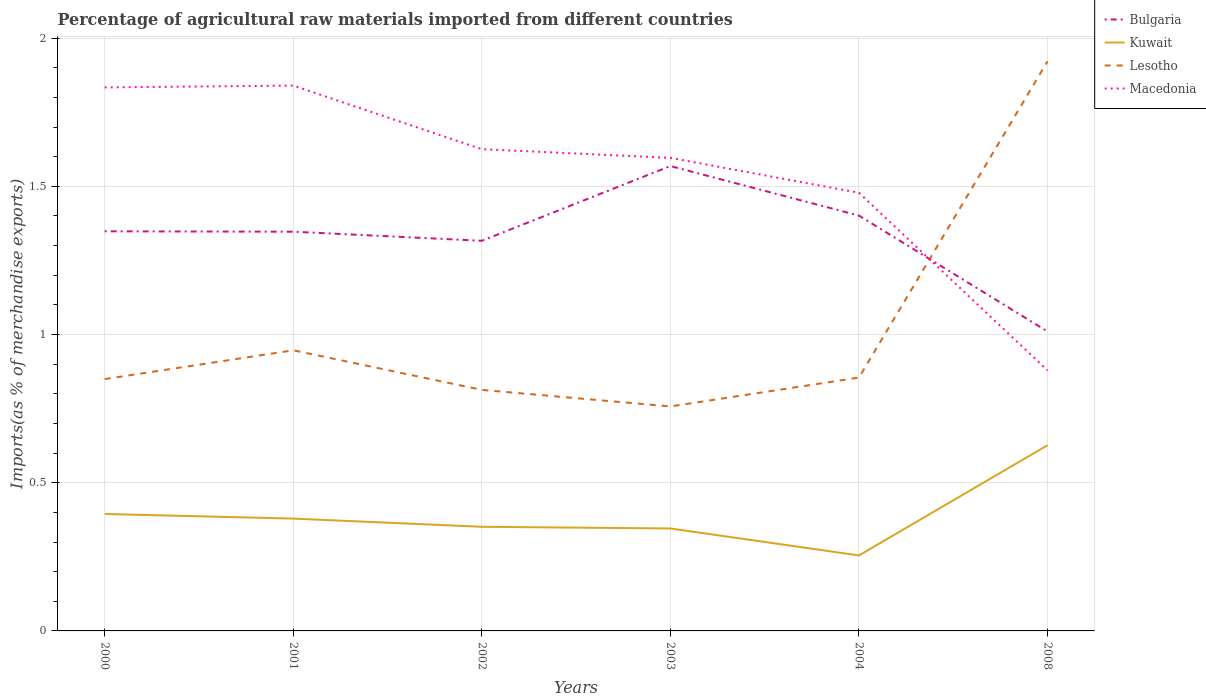How many different coloured lines are there?
Your response must be concise. 4. Is the number of lines equal to the number of legend labels?
Ensure brevity in your answer.  Yes. Across all years, what is the maximum percentage of imports to different countries in Bulgaria?
Provide a succinct answer. 1.01. What is the total percentage of imports to different countries in Kuwait in the graph?
Keep it short and to the point. 0.09. What is the difference between the highest and the second highest percentage of imports to different countries in Macedonia?
Your response must be concise. 0.96. What is the difference between the highest and the lowest percentage of imports to different countries in Bulgaria?
Keep it short and to the point. 4. How many lines are there?
Provide a succinct answer. 4. How are the legend labels stacked?
Keep it short and to the point. Vertical. What is the title of the graph?
Your response must be concise. Percentage of agricultural raw materials imported from different countries. Does "Kiribati" appear as one of the legend labels in the graph?
Ensure brevity in your answer.  No. What is the label or title of the X-axis?
Your answer should be compact. Years. What is the label or title of the Y-axis?
Offer a very short reply. Imports(as % of merchandise exports). What is the Imports(as % of merchandise exports) in Bulgaria in 2000?
Your answer should be compact. 1.35. What is the Imports(as % of merchandise exports) of Kuwait in 2000?
Ensure brevity in your answer.  0.39. What is the Imports(as % of merchandise exports) in Lesotho in 2000?
Your answer should be very brief. 0.85. What is the Imports(as % of merchandise exports) of Macedonia in 2000?
Your answer should be very brief. 1.83. What is the Imports(as % of merchandise exports) in Bulgaria in 2001?
Offer a very short reply. 1.35. What is the Imports(as % of merchandise exports) in Kuwait in 2001?
Keep it short and to the point. 0.38. What is the Imports(as % of merchandise exports) of Lesotho in 2001?
Provide a short and direct response. 0.95. What is the Imports(as % of merchandise exports) of Macedonia in 2001?
Offer a terse response. 1.84. What is the Imports(as % of merchandise exports) of Bulgaria in 2002?
Offer a very short reply. 1.32. What is the Imports(as % of merchandise exports) of Kuwait in 2002?
Offer a terse response. 0.35. What is the Imports(as % of merchandise exports) in Lesotho in 2002?
Your answer should be compact. 0.81. What is the Imports(as % of merchandise exports) of Macedonia in 2002?
Your answer should be very brief. 1.63. What is the Imports(as % of merchandise exports) in Bulgaria in 2003?
Offer a terse response. 1.57. What is the Imports(as % of merchandise exports) of Kuwait in 2003?
Keep it short and to the point. 0.35. What is the Imports(as % of merchandise exports) of Lesotho in 2003?
Keep it short and to the point. 0.76. What is the Imports(as % of merchandise exports) in Macedonia in 2003?
Ensure brevity in your answer.  1.6. What is the Imports(as % of merchandise exports) of Bulgaria in 2004?
Offer a terse response. 1.4. What is the Imports(as % of merchandise exports) in Kuwait in 2004?
Provide a short and direct response. 0.25. What is the Imports(as % of merchandise exports) in Lesotho in 2004?
Keep it short and to the point. 0.85. What is the Imports(as % of merchandise exports) of Macedonia in 2004?
Keep it short and to the point. 1.48. What is the Imports(as % of merchandise exports) of Bulgaria in 2008?
Provide a succinct answer. 1.01. What is the Imports(as % of merchandise exports) in Kuwait in 2008?
Your response must be concise. 0.63. What is the Imports(as % of merchandise exports) of Lesotho in 2008?
Your answer should be compact. 1.92. What is the Imports(as % of merchandise exports) in Macedonia in 2008?
Your answer should be compact. 0.88. Across all years, what is the maximum Imports(as % of merchandise exports) of Bulgaria?
Ensure brevity in your answer.  1.57. Across all years, what is the maximum Imports(as % of merchandise exports) in Kuwait?
Your response must be concise. 0.63. Across all years, what is the maximum Imports(as % of merchandise exports) of Lesotho?
Give a very brief answer. 1.92. Across all years, what is the maximum Imports(as % of merchandise exports) of Macedonia?
Your response must be concise. 1.84. Across all years, what is the minimum Imports(as % of merchandise exports) of Bulgaria?
Offer a very short reply. 1.01. Across all years, what is the minimum Imports(as % of merchandise exports) in Kuwait?
Offer a very short reply. 0.25. Across all years, what is the minimum Imports(as % of merchandise exports) of Lesotho?
Provide a succinct answer. 0.76. Across all years, what is the minimum Imports(as % of merchandise exports) in Macedonia?
Keep it short and to the point. 0.88. What is the total Imports(as % of merchandise exports) in Bulgaria in the graph?
Keep it short and to the point. 7.99. What is the total Imports(as % of merchandise exports) of Kuwait in the graph?
Give a very brief answer. 2.35. What is the total Imports(as % of merchandise exports) in Lesotho in the graph?
Provide a succinct answer. 6.14. What is the total Imports(as % of merchandise exports) of Macedonia in the graph?
Offer a terse response. 9.25. What is the difference between the Imports(as % of merchandise exports) of Bulgaria in 2000 and that in 2001?
Ensure brevity in your answer.  0. What is the difference between the Imports(as % of merchandise exports) of Kuwait in 2000 and that in 2001?
Your answer should be compact. 0.02. What is the difference between the Imports(as % of merchandise exports) in Lesotho in 2000 and that in 2001?
Ensure brevity in your answer.  -0.1. What is the difference between the Imports(as % of merchandise exports) of Macedonia in 2000 and that in 2001?
Your answer should be compact. -0.01. What is the difference between the Imports(as % of merchandise exports) of Bulgaria in 2000 and that in 2002?
Provide a short and direct response. 0.03. What is the difference between the Imports(as % of merchandise exports) of Kuwait in 2000 and that in 2002?
Your answer should be compact. 0.04. What is the difference between the Imports(as % of merchandise exports) of Lesotho in 2000 and that in 2002?
Your answer should be very brief. 0.04. What is the difference between the Imports(as % of merchandise exports) in Macedonia in 2000 and that in 2002?
Give a very brief answer. 0.21. What is the difference between the Imports(as % of merchandise exports) in Bulgaria in 2000 and that in 2003?
Offer a terse response. -0.22. What is the difference between the Imports(as % of merchandise exports) of Kuwait in 2000 and that in 2003?
Give a very brief answer. 0.05. What is the difference between the Imports(as % of merchandise exports) of Lesotho in 2000 and that in 2003?
Your answer should be very brief. 0.09. What is the difference between the Imports(as % of merchandise exports) in Macedonia in 2000 and that in 2003?
Ensure brevity in your answer.  0.24. What is the difference between the Imports(as % of merchandise exports) in Bulgaria in 2000 and that in 2004?
Your answer should be very brief. -0.05. What is the difference between the Imports(as % of merchandise exports) in Kuwait in 2000 and that in 2004?
Your answer should be very brief. 0.14. What is the difference between the Imports(as % of merchandise exports) of Lesotho in 2000 and that in 2004?
Your answer should be compact. -0.01. What is the difference between the Imports(as % of merchandise exports) of Macedonia in 2000 and that in 2004?
Keep it short and to the point. 0.36. What is the difference between the Imports(as % of merchandise exports) of Bulgaria in 2000 and that in 2008?
Make the answer very short. 0.34. What is the difference between the Imports(as % of merchandise exports) in Kuwait in 2000 and that in 2008?
Your response must be concise. -0.23. What is the difference between the Imports(as % of merchandise exports) of Lesotho in 2000 and that in 2008?
Your answer should be compact. -1.07. What is the difference between the Imports(as % of merchandise exports) in Macedonia in 2000 and that in 2008?
Ensure brevity in your answer.  0.95. What is the difference between the Imports(as % of merchandise exports) in Bulgaria in 2001 and that in 2002?
Provide a succinct answer. 0.03. What is the difference between the Imports(as % of merchandise exports) in Kuwait in 2001 and that in 2002?
Your answer should be compact. 0.03. What is the difference between the Imports(as % of merchandise exports) in Lesotho in 2001 and that in 2002?
Offer a very short reply. 0.13. What is the difference between the Imports(as % of merchandise exports) in Macedonia in 2001 and that in 2002?
Offer a very short reply. 0.21. What is the difference between the Imports(as % of merchandise exports) in Bulgaria in 2001 and that in 2003?
Keep it short and to the point. -0.22. What is the difference between the Imports(as % of merchandise exports) in Lesotho in 2001 and that in 2003?
Your response must be concise. 0.19. What is the difference between the Imports(as % of merchandise exports) in Macedonia in 2001 and that in 2003?
Ensure brevity in your answer.  0.24. What is the difference between the Imports(as % of merchandise exports) of Bulgaria in 2001 and that in 2004?
Your answer should be very brief. -0.05. What is the difference between the Imports(as % of merchandise exports) in Kuwait in 2001 and that in 2004?
Offer a very short reply. 0.12. What is the difference between the Imports(as % of merchandise exports) in Lesotho in 2001 and that in 2004?
Provide a succinct answer. 0.09. What is the difference between the Imports(as % of merchandise exports) of Macedonia in 2001 and that in 2004?
Your answer should be compact. 0.36. What is the difference between the Imports(as % of merchandise exports) of Bulgaria in 2001 and that in 2008?
Your answer should be very brief. 0.34. What is the difference between the Imports(as % of merchandise exports) of Kuwait in 2001 and that in 2008?
Give a very brief answer. -0.25. What is the difference between the Imports(as % of merchandise exports) of Lesotho in 2001 and that in 2008?
Your answer should be compact. -0.98. What is the difference between the Imports(as % of merchandise exports) in Macedonia in 2001 and that in 2008?
Your answer should be very brief. 0.96. What is the difference between the Imports(as % of merchandise exports) in Bulgaria in 2002 and that in 2003?
Provide a short and direct response. -0.25. What is the difference between the Imports(as % of merchandise exports) in Kuwait in 2002 and that in 2003?
Your answer should be very brief. 0.01. What is the difference between the Imports(as % of merchandise exports) in Lesotho in 2002 and that in 2003?
Your response must be concise. 0.06. What is the difference between the Imports(as % of merchandise exports) of Macedonia in 2002 and that in 2003?
Provide a succinct answer. 0.03. What is the difference between the Imports(as % of merchandise exports) in Bulgaria in 2002 and that in 2004?
Your answer should be compact. -0.09. What is the difference between the Imports(as % of merchandise exports) of Kuwait in 2002 and that in 2004?
Your response must be concise. 0.1. What is the difference between the Imports(as % of merchandise exports) in Lesotho in 2002 and that in 2004?
Provide a short and direct response. -0.04. What is the difference between the Imports(as % of merchandise exports) of Macedonia in 2002 and that in 2004?
Keep it short and to the point. 0.15. What is the difference between the Imports(as % of merchandise exports) of Bulgaria in 2002 and that in 2008?
Make the answer very short. 0.31. What is the difference between the Imports(as % of merchandise exports) of Kuwait in 2002 and that in 2008?
Give a very brief answer. -0.28. What is the difference between the Imports(as % of merchandise exports) in Lesotho in 2002 and that in 2008?
Offer a very short reply. -1.11. What is the difference between the Imports(as % of merchandise exports) of Macedonia in 2002 and that in 2008?
Make the answer very short. 0.75. What is the difference between the Imports(as % of merchandise exports) of Bulgaria in 2003 and that in 2004?
Give a very brief answer. 0.17. What is the difference between the Imports(as % of merchandise exports) of Kuwait in 2003 and that in 2004?
Ensure brevity in your answer.  0.09. What is the difference between the Imports(as % of merchandise exports) of Lesotho in 2003 and that in 2004?
Give a very brief answer. -0.1. What is the difference between the Imports(as % of merchandise exports) of Macedonia in 2003 and that in 2004?
Offer a terse response. 0.12. What is the difference between the Imports(as % of merchandise exports) of Bulgaria in 2003 and that in 2008?
Offer a very short reply. 0.56. What is the difference between the Imports(as % of merchandise exports) of Kuwait in 2003 and that in 2008?
Your answer should be compact. -0.28. What is the difference between the Imports(as % of merchandise exports) of Lesotho in 2003 and that in 2008?
Keep it short and to the point. -1.16. What is the difference between the Imports(as % of merchandise exports) of Macedonia in 2003 and that in 2008?
Ensure brevity in your answer.  0.72. What is the difference between the Imports(as % of merchandise exports) of Bulgaria in 2004 and that in 2008?
Your answer should be compact. 0.39. What is the difference between the Imports(as % of merchandise exports) of Kuwait in 2004 and that in 2008?
Make the answer very short. -0.37. What is the difference between the Imports(as % of merchandise exports) in Lesotho in 2004 and that in 2008?
Keep it short and to the point. -1.07. What is the difference between the Imports(as % of merchandise exports) of Macedonia in 2004 and that in 2008?
Ensure brevity in your answer.  0.6. What is the difference between the Imports(as % of merchandise exports) of Bulgaria in 2000 and the Imports(as % of merchandise exports) of Kuwait in 2001?
Keep it short and to the point. 0.97. What is the difference between the Imports(as % of merchandise exports) of Bulgaria in 2000 and the Imports(as % of merchandise exports) of Lesotho in 2001?
Offer a very short reply. 0.4. What is the difference between the Imports(as % of merchandise exports) in Bulgaria in 2000 and the Imports(as % of merchandise exports) in Macedonia in 2001?
Make the answer very short. -0.49. What is the difference between the Imports(as % of merchandise exports) in Kuwait in 2000 and the Imports(as % of merchandise exports) in Lesotho in 2001?
Provide a succinct answer. -0.55. What is the difference between the Imports(as % of merchandise exports) in Kuwait in 2000 and the Imports(as % of merchandise exports) in Macedonia in 2001?
Offer a very short reply. -1.45. What is the difference between the Imports(as % of merchandise exports) in Lesotho in 2000 and the Imports(as % of merchandise exports) in Macedonia in 2001?
Offer a terse response. -0.99. What is the difference between the Imports(as % of merchandise exports) in Bulgaria in 2000 and the Imports(as % of merchandise exports) in Kuwait in 2002?
Offer a very short reply. 1. What is the difference between the Imports(as % of merchandise exports) in Bulgaria in 2000 and the Imports(as % of merchandise exports) in Lesotho in 2002?
Offer a terse response. 0.54. What is the difference between the Imports(as % of merchandise exports) in Bulgaria in 2000 and the Imports(as % of merchandise exports) in Macedonia in 2002?
Your answer should be very brief. -0.28. What is the difference between the Imports(as % of merchandise exports) in Kuwait in 2000 and the Imports(as % of merchandise exports) in Lesotho in 2002?
Ensure brevity in your answer.  -0.42. What is the difference between the Imports(as % of merchandise exports) of Kuwait in 2000 and the Imports(as % of merchandise exports) of Macedonia in 2002?
Offer a terse response. -1.23. What is the difference between the Imports(as % of merchandise exports) of Lesotho in 2000 and the Imports(as % of merchandise exports) of Macedonia in 2002?
Make the answer very short. -0.78. What is the difference between the Imports(as % of merchandise exports) of Bulgaria in 2000 and the Imports(as % of merchandise exports) of Kuwait in 2003?
Provide a succinct answer. 1. What is the difference between the Imports(as % of merchandise exports) in Bulgaria in 2000 and the Imports(as % of merchandise exports) in Lesotho in 2003?
Provide a succinct answer. 0.59. What is the difference between the Imports(as % of merchandise exports) in Bulgaria in 2000 and the Imports(as % of merchandise exports) in Macedonia in 2003?
Provide a succinct answer. -0.25. What is the difference between the Imports(as % of merchandise exports) of Kuwait in 2000 and the Imports(as % of merchandise exports) of Lesotho in 2003?
Keep it short and to the point. -0.36. What is the difference between the Imports(as % of merchandise exports) of Kuwait in 2000 and the Imports(as % of merchandise exports) of Macedonia in 2003?
Make the answer very short. -1.2. What is the difference between the Imports(as % of merchandise exports) in Lesotho in 2000 and the Imports(as % of merchandise exports) in Macedonia in 2003?
Offer a very short reply. -0.75. What is the difference between the Imports(as % of merchandise exports) of Bulgaria in 2000 and the Imports(as % of merchandise exports) of Kuwait in 2004?
Offer a terse response. 1.09. What is the difference between the Imports(as % of merchandise exports) in Bulgaria in 2000 and the Imports(as % of merchandise exports) in Lesotho in 2004?
Give a very brief answer. 0.49. What is the difference between the Imports(as % of merchandise exports) of Bulgaria in 2000 and the Imports(as % of merchandise exports) of Macedonia in 2004?
Offer a terse response. -0.13. What is the difference between the Imports(as % of merchandise exports) in Kuwait in 2000 and the Imports(as % of merchandise exports) in Lesotho in 2004?
Provide a short and direct response. -0.46. What is the difference between the Imports(as % of merchandise exports) in Kuwait in 2000 and the Imports(as % of merchandise exports) in Macedonia in 2004?
Offer a very short reply. -1.08. What is the difference between the Imports(as % of merchandise exports) of Lesotho in 2000 and the Imports(as % of merchandise exports) of Macedonia in 2004?
Keep it short and to the point. -0.63. What is the difference between the Imports(as % of merchandise exports) of Bulgaria in 2000 and the Imports(as % of merchandise exports) of Kuwait in 2008?
Your answer should be compact. 0.72. What is the difference between the Imports(as % of merchandise exports) in Bulgaria in 2000 and the Imports(as % of merchandise exports) in Lesotho in 2008?
Provide a succinct answer. -0.57. What is the difference between the Imports(as % of merchandise exports) in Bulgaria in 2000 and the Imports(as % of merchandise exports) in Macedonia in 2008?
Give a very brief answer. 0.47. What is the difference between the Imports(as % of merchandise exports) in Kuwait in 2000 and the Imports(as % of merchandise exports) in Lesotho in 2008?
Make the answer very short. -1.53. What is the difference between the Imports(as % of merchandise exports) of Kuwait in 2000 and the Imports(as % of merchandise exports) of Macedonia in 2008?
Keep it short and to the point. -0.48. What is the difference between the Imports(as % of merchandise exports) in Lesotho in 2000 and the Imports(as % of merchandise exports) in Macedonia in 2008?
Provide a short and direct response. -0.03. What is the difference between the Imports(as % of merchandise exports) in Bulgaria in 2001 and the Imports(as % of merchandise exports) in Lesotho in 2002?
Offer a very short reply. 0.53. What is the difference between the Imports(as % of merchandise exports) of Bulgaria in 2001 and the Imports(as % of merchandise exports) of Macedonia in 2002?
Your response must be concise. -0.28. What is the difference between the Imports(as % of merchandise exports) in Kuwait in 2001 and the Imports(as % of merchandise exports) in Lesotho in 2002?
Offer a terse response. -0.43. What is the difference between the Imports(as % of merchandise exports) in Kuwait in 2001 and the Imports(as % of merchandise exports) in Macedonia in 2002?
Provide a short and direct response. -1.25. What is the difference between the Imports(as % of merchandise exports) of Lesotho in 2001 and the Imports(as % of merchandise exports) of Macedonia in 2002?
Offer a terse response. -0.68. What is the difference between the Imports(as % of merchandise exports) in Bulgaria in 2001 and the Imports(as % of merchandise exports) in Lesotho in 2003?
Your answer should be very brief. 0.59. What is the difference between the Imports(as % of merchandise exports) in Bulgaria in 2001 and the Imports(as % of merchandise exports) in Macedonia in 2003?
Offer a terse response. -0.25. What is the difference between the Imports(as % of merchandise exports) in Kuwait in 2001 and the Imports(as % of merchandise exports) in Lesotho in 2003?
Offer a very short reply. -0.38. What is the difference between the Imports(as % of merchandise exports) of Kuwait in 2001 and the Imports(as % of merchandise exports) of Macedonia in 2003?
Provide a succinct answer. -1.22. What is the difference between the Imports(as % of merchandise exports) of Lesotho in 2001 and the Imports(as % of merchandise exports) of Macedonia in 2003?
Ensure brevity in your answer.  -0.65. What is the difference between the Imports(as % of merchandise exports) in Bulgaria in 2001 and the Imports(as % of merchandise exports) in Kuwait in 2004?
Keep it short and to the point. 1.09. What is the difference between the Imports(as % of merchandise exports) in Bulgaria in 2001 and the Imports(as % of merchandise exports) in Lesotho in 2004?
Make the answer very short. 0.49. What is the difference between the Imports(as % of merchandise exports) of Bulgaria in 2001 and the Imports(as % of merchandise exports) of Macedonia in 2004?
Offer a terse response. -0.13. What is the difference between the Imports(as % of merchandise exports) in Kuwait in 2001 and the Imports(as % of merchandise exports) in Lesotho in 2004?
Keep it short and to the point. -0.48. What is the difference between the Imports(as % of merchandise exports) of Kuwait in 2001 and the Imports(as % of merchandise exports) of Macedonia in 2004?
Your answer should be compact. -1.1. What is the difference between the Imports(as % of merchandise exports) in Lesotho in 2001 and the Imports(as % of merchandise exports) in Macedonia in 2004?
Make the answer very short. -0.53. What is the difference between the Imports(as % of merchandise exports) of Bulgaria in 2001 and the Imports(as % of merchandise exports) of Kuwait in 2008?
Give a very brief answer. 0.72. What is the difference between the Imports(as % of merchandise exports) of Bulgaria in 2001 and the Imports(as % of merchandise exports) of Lesotho in 2008?
Make the answer very short. -0.57. What is the difference between the Imports(as % of merchandise exports) of Bulgaria in 2001 and the Imports(as % of merchandise exports) of Macedonia in 2008?
Your response must be concise. 0.47. What is the difference between the Imports(as % of merchandise exports) in Kuwait in 2001 and the Imports(as % of merchandise exports) in Lesotho in 2008?
Your response must be concise. -1.54. What is the difference between the Imports(as % of merchandise exports) in Kuwait in 2001 and the Imports(as % of merchandise exports) in Macedonia in 2008?
Offer a terse response. -0.5. What is the difference between the Imports(as % of merchandise exports) in Lesotho in 2001 and the Imports(as % of merchandise exports) in Macedonia in 2008?
Keep it short and to the point. 0.07. What is the difference between the Imports(as % of merchandise exports) of Bulgaria in 2002 and the Imports(as % of merchandise exports) of Kuwait in 2003?
Offer a very short reply. 0.97. What is the difference between the Imports(as % of merchandise exports) in Bulgaria in 2002 and the Imports(as % of merchandise exports) in Lesotho in 2003?
Make the answer very short. 0.56. What is the difference between the Imports(as % of merchandise exports) of Bulgaria in 2002 and the Imports(as % of merchandise exports) of Macedonia in 2003?
Keep it short and to the point. -0.28. What is the difference between the Imports(as % of merchandise exports) of Kuwait in 2002 and the Imports(as % of merchandise exports) of Lesotho in 2003?
Make the answer very short. -0.41. What is the difference between the Imports(as % of merchandise exports) of Kuwait in 2002 and the Imports(as % of merchandise exports) of Macedonia in 2003?
Offer a terse response. -1.24. What is the difference between the Imports(as % of merchandise exports) in Lesotho in 2002 and the Imports(as % of merchandise exports) in Macedonia in 2003?
Offer a very short reply. -0.78. What is the difference between the Imports(as % of merchandise exports) in Bulgaria in 2002 and the Imports(as % of merchandise exports) in Kuwait in 2004?
Your response must be concise. 1.06. What is the difference between the Imports(as % of merchandise exports) in Bulgaria in 2002 and the Imports(as % of merchandise exports) in Lesotho in 2004?
Provide a short and direct response. 0.46. What is the difference between the Imports(as % of merchandise exports) of Bulgaria in 2002 and the Imports(as % of merchandise exports) of Macedonia in 2004?
Your answer should be compact. -0.16. What is the difference between the Imports(as % of merchandise exports) of Kuwait in 2002 and the Imports(as % of merchandise exports) of Lesotho in 2004?
Your answer should be compact. -0.5. What is the difference between the Imports(as % of merchandise exports) of Kuwait in 2002 and the Imports(as % of merchandise exports) of Macedonia in 2004?
Keep it short and to the point. -1.13. What is the difference between the Imports(as % of merchandise exports) of Lesotho in 2002 and the Imports(as % of merchandise exports) of Macedonia in 2004?
Your answer should be very brief. -0.67. What is the difference between the Imports(as % of merchandise exports) in Bulgaria in 2002 and the Imports(as % of merchandise exports) in Kuwait in 2008?
Ensure brevity in your answer.  0.69. What is the difference between the Imports(as % of merchandise exports) in Bulgaria in 2002 and the Imports(as % of merchandise exports) in Lesotho in 2008?
Keep it short and to the point. -0.61. What is the difference between the Imports(as % of merchandise exports) of Bulgaria in 2002 and the Imports(as % of merchandise exports) of Macedonia in 2008?
Provide a short and direct response. 0.44. What is the difference between the Imports(as % of merchandise exports) in Kuwait in 2002 and the Imports(as % of merchandise exports) in Lesotho in 2008?
Keep it short and to the point. -1.57. What is the difference between the Imports(as % of merchandise exports) in Kuwait in 2002 and the Imports(as % of merchandise exports) in Macedonia in 2008?
Keep it short and to the point. -0.53. What is the difference between the Imports(as % of merchandise exports) in Lesotho in 2002 and the Imports(as % of merchandise exports) in Macedonia in 2008?
Provide a short and direct response. -0.07. What is the difference between the Imports(as % of merchandise exports) of Bulgaria in 2003 and the Imports(as % of merchandise exports) of Kuwait in 2004?
Offer a terse response. 1.31. What is the difference between the Imports(as % of merchandise exports) of Bulgaria in 2003 and the Imports(as % of merchandise exports) of Lesotho in 2004?
Provide a succinct answer. 0.71. What is the difference between the Imports(as % of merchandise exports) of Bulgaria in 2003 and the Imports(as % of merchandise exports) of Macedonia in 2004?
Offer a terse response. 0.09. What is the difference between the Imports(as % of merchandise exports) of Kuwait in 2003 and the Imports(as % of merchandise exports) of Lesotho in 2004?
Provide a short and direct response. -0.51. What is the difference between the Imports(as % of merchandise exports) of Kuwait in 2003 and the Imports(as % of merchandise exports) of Macedonia in 2004?
Offer a terse response. -1.13. What is the difference between the Imports(as % of merchandise exports) in Lesotho in 2003 and the Imports(as % of merchandise exports) in Macedonia in 2004?
Your response must be concise. -0.72. What is the difference between the Imports(as % of merchandise exports) in Bulgaria in 2003 and the Imports(as % of merchandise exports) in Kuwait in 2008?
Ensure brevity in your answer.  0.94. What is the difference between the Imports(as % of merchandise exports) in Bulgaria in 2003 and the Imports(as % of merchandise exports) in Lesotho in 2008?
Keep it short and to the point. -0.35. What is the difference between the Imports(as % of merchandise exports) of Bulgaria in 2003 and the Imports(as % of merchandise exports) of Macedonia in 2008?
Make the answer very short. 0.69. What is the difference between the Imports(as % of merchandise exports) in Kuwait in 2003 and the Imports(as % of merchandise exports) in Lesotho in 2008?
Your answer should be very brief. -1.58. What is the difference between the Imports(as % of merchandise exports) of Kuwait in 2003 and the Imports(as % of merchandise exports) of Macedonia in 2008?
Your answer should be very brief. -0.53. What is the difference between the Imports(as % of merchandise exports) of Lesotho in 2003 and the Imports(as % of merchandise exports) of Macedonia in 2008?
Your response must be concise. -0.12. What is the difference between the Imports(as % of merchandise exports) in Bulgaria in 2004 and the Imports(as % of merchandise exports) in Kuwait in 2008?
Your response must be concise. 0.77. What is the difference between the Imports(as % of merchandise exports) of Bulgaria in 2004 and the Imports(as % of merchandise exports) of Lesotho in 2008?
Provide a short and direct response. -0.52. What is the difference between the Imports(as % of merchandise exports) of Bulgaria in 2004 and the Imports(as % of merchandise exports) of Macedonia in 2008?
Your answer should be very brief. 0.52. What is the difference between the Imports(as % of merchandise exports) of Kuwait in 2004 and the Imports(as % of merchandise exports) of Lesotho in 2008?
Offer a very short reply. -1.67. What is the difference between the Imports(as % of merchandise exports) of Kuwait in 2004 and the Imports(as % of merchandise exports) of Macedonia in 2008?
Keep it short and to the point. -0.62. What is the difference between the Imports(as % of merchandise exports) in Lesotho in 2004 and the Imports(as % of merchandise exports) in Macedonia in 2008?
Provide a succinct answer. -0.02. What is the average Imports(as % of merchandise exports) in Bulgaria per year?
Your answer should be very brief. 1.33. What is the average Imports(as % of merchandise exports) in Kuwait per year?
Provide a short and direct response. 0.39. What is the average Imports(as % of merchandise exports) in Lesotho per year?
Your answer should be very brief. 1.02. What is the average Imports(as % of merchandise exports) of Macedonia per year?
Provide a succinct answer. 1.54. In the year 2000, what is the difference between the Imports(as % of merchandise exports) of Bulgaria and Imports(as % of merchandise exports) of Kuwait?
Your answer should be very brief. 0.95. In the year 2000, what is the difference between the Imports(as % of merchandise exports) of Bulgaria and Imports(as % of merchandise exports) of Lesotho?
Offer a very short reply. 0.5. In the year 2000, what is the difference between the Imports(as % of merchandise exports) in Bulgaria and Imports(as % of merchandise exports) in Macedonia?
Provide a succinct answer. -0.49. In the year 2000, what is the difference between the Imports(as % of merchandise exports) of Kuwait and Imports(as % of merchandise exports) of Lesotho?
Give a very brief answer. -0.46. In the year 2000, what is the difference between the Imports(as % of merchandise exports) in Kuwait and Imports(as % of merchandise exports) in Macedonia?
Make the answer very short. -1.44. In the year 2000, what is the difference between the Imports(as % of merchandise exports) in Lesotho and Imports(as % of merchandise exports) in Macedonia?
Provide a short and direct response. -0.98. In the year 2001, what is the difference between the Imports(as % of merchandise exports) of Bulgaria and Imports(as % of merchandise exports) of Kuwait?
Make the answer very short. 0.97. In the year 2001, what is the difference between the Imports(as % of merchandise exports) in Bulgaria and Imports(as % of merchandise exports) in Lesotho?
Offer a very short reply. 0.4. In the year 2001, what is the difference between the Imports(as % of merchandise exports) in Bulgaria and Imports(as % of merchandise exports) in Macedonia?
Ensure brevity in your answer.  -0.49. In the year 2001, what is the difference between the Imports(as % of merchandise exports) of Kuwait and Imports(as % of merchandise exports) of Lesotho?
Keep it short and to the point. -0.57. In the year 2001, what is the difference between the Imports(as % of merchandise exports) in Kuwait and Imports(as % of merchandise exports) in Macedonia?
Your answer should be compact. -1.46. In the year 2001, what is the difference between the Imports(as % of merchandise exports) of Lesotho and Imports(as % of merchandise exports) of Macedonia?
Your response must be concise. -0.89. In the year 2002, what is the difference between the Imports(as % of merchandise exports) in Bulgaria and Imports(as % of merchandise exports) in Kuwait?
Ensure brevity in your answer.  0.96. In the year 2002, what is the difference between the Imports(as % of merchandise exports) of Bulgaria and Imports(as % of merchandise exports) of Lesotho?
Your answer should be compact. 0.5. In the year 2002, what is the difference between the Imports(as % of merchandise exports) of Bulgaria and Imports(as % of merchandise exports) of Macedonia?
Your answer should be very brief. -0.31. In the year 2002, what is the difference between the Imports(as % of merchandise exports) of Kuwait and Imports(as % of merchandise exports) of Lesotho?
Your answer should be compact. -0.46. In the year 2002, what is the difference between the Imports(as % of merchandise exports) of Kuwait and Imports(as % of merchandise exports) of Macedonia?
Your answer should be very brief. -1.27. In the year 2002, what is the difference between the Imports(as % of merchandise exports) of Lesotho and Imports(as % of merchandise exports) of Macedonia?
Provide a succinct answer. -0.81. In the year 2003, what is the difference between the Imports(as % of merchandise exports) of Bulgaria and Imports(as % of merchandise exports) of Kuwait?
Your response must be concise. 1.22. In the year 2003, what is the difference between the Imports(as % of merchandise exports) in Bulgaria and Imports(as % of merchandise exports) in Lesotho?
Keep it short and to the point. 0.81. In the year 2003, what is the difference between the Imports(as % of merchandise exports) of Bulgaria and Imports(as % of merchandise exports) of Macedonia?
Your response must be concise. -0.03. In the year 2003, what is the difference between the Imports(as % of merchandise exports) of Kuwait and Imports(as % of merchandise exports) of Lesotho?
Offer a terse response. -0.41. In the year 2003, what is the difference between the Imports(as % of merchandise exports) of Kuwait and Imports(as % of merchandise exports) of Macedonia?
Offer a terse response. -1.25. In the year 2003, what is the difference between the Imports(as % of merchandise exports) in Lesotho and Imports(as % of merchandise exports) in Macedonia?
Make the answer very short. -0.84. In the year 2004, what is the difference between the Imports(as % of merchandise exports) of Bulgaria and Imports(as % of merchandise exports) of Kuwait?
Your answer should be compact. 1.15. In the year 2004, what is the difference between the Imports(as % of merchandise exports) in Bulgaria and Imports(as % of merchandise exports) in Lesotho?
Offer a very short reply. 0.55. In the year 2004, what is the difference between the Imports(as % of merchandise exports) of Bulgaria and Imports(as % of merchandise exports) of Macedonia?
Keep it short and to the point. -0.08. In the year 2004, what is the difference between the Imports(as % of merchandise exports) of Kuwait and Imports(as % of merchandise exports) of Lesotho?
Make the answer very short. -0.6. In the year 2004, what is the difference between the Imports(as % of merchandise exports) in Kuwait and Imports(as % of merchandise exports) in Macedonia?
Provide a short and direct response. -1.22. In the year 2004, what is the difference between the Imports(as % of merchandise exports) in Lesotho and Imports(as % of merchandise exports) in Macedonia?
Ensure brevity in your answer.  -0.62. In the year 2008, what is the difference between the Imports(as % of merchandise exports) of Bulgaria and Imports(as % of merchandise exports) of Kuwait?
Offer a terse response. 0.38. In the year 2008, what is the difference between the Imports(as % of merchandise exports) of Bulgaria and Imports(as % of merchandise exports) of Lesotho?
Your answer should be very brief. -0.91. In the year 2008, what is the difference between the Imports(as % of merchandise exports) of Bulgaria and Imports(as % of merchandise exports) of Macedonia?
Ensure brevity in your answer.  0.13. In the year 2008, what is the difference between the Imports(as % of merchandise exports) of Kuwait and Imports(as % of merchandise exports) of Lesotho?
Make the answer very short. -1.3. In the year 2008, what is the difference between the Imports(as % of merchandise exports) in Kuwait and Imports(as % of merchandise exports) in Macedonia?
Your response must be concise. -0.25. In the year 2008, what is the difference between the Imports(as % of merchandise exports) in Lesotho and Imports(as % of merchandise exports) in Macedonia?
Offer a very short reply. 1.04. What is the ratio of the Imports(as % of merchandise exports) in Bulgaria in 2000 to that in 2001?
Give a very brief answer. 1. What is the ratio of the Imports(as % of merchandise exports) of Kuwait in 2000 to that in 2001?
Make the answer very short. 1.04. What is the ratio of the Imports(as % of merchandise exports) of Lesotho in 2000 to that in 2001?
Ensure brevity in your answer.  0.9. What is the ratio of the Imports(as % of merchandise exports) of Macedonia in 2000 to that in 2001?
Give a very brief answer. 1. What is the ratio of the Imports(as % of merchandise exports) of Bulgaria in 2000 to that in 2002?
Your answer should be very brief. 1.02. What is the ratio of the Imports(as % of merchandise exports) in Kuwait in 2000 to that in 2002?
Your answer should be very brief. 1.12. What is the ratio of the Imports(as % of merchandise exports) of Lesotho in 2000 to that in 2002?
Ensure brevity in your answer.  1.04. What is the ratio of the Imports(as % of merchandise exports) in Macedonia in 2000 to that in 2002?
Provide a short and direct response. 1.13. What is the ratio of the Imports(as % of merchandise exports) in Bulgaria in 2000 to that in 2003?
Ensure brevity in your answer.  0.86. What is the ratio of the Imports(as % of merchandise exports) in Kuwait in 2000 to that in 2003?
Give a very brief answer. 1.14. What is the ratio of the Imports(as % of merchandise exports) in Lesotho in 2000 to that in 2003?
Offer a very short reply. 1.12. What is the ratio of the Imports(as % of merchandise exports) of Macedonia in 2000 to that in 2003?
Make the answer very short. 1.15. What is the ratio of the Imports(as % of merchandise exports) in Bulgaria in 2000 to that in 2004?
Give a very brief answer. 0.96. What is the ratio of the Imports(as % of merchandise exports) in Kuwait in 2000 to that in 2004?
Provide a short and direct response. 1.55. What is the ratio of the Imports(as % of merchandise exports) of Macedonia in 2000 to that in 2004?
Your answer should be compact. 1.24. What is the ratio of the Imports(as % of merchandise exports) of Bulgaria in 2000 to that in 2008?
Keep it short and to the point. 1.33. What is the ratio of the Imports(as % of merchandise exports) in Kuwait in 2000 to that in 2008?
Give a very brief answer. 0.63. What is the ratio of the Imports(as % of merchandise exports) of Lesotho in 2000 to that in 2008?
Give a very brief answer. 0.44. What is the ratio of the Imports(as % of merchandise exports) in Macedonia in 2000 to that in 2008?
Keep it short and to the point. 2.09. What is the ratio of the Imports(as % of merchandise exports) of Bulgaria in 2001 to that in 2002?
Ensure brevity in your answer.  1.02. What is the ratio of the Imports(as % of merchandise exports) of Kuwait in 2001 to that in 2002?
Make the answer very short. 1.08. What is the ratio of the Imports(as % of merchandise exports) in Lesotho in 2001 to that in 2002?
Offer a terse response. 1.16. What is the ratio of the Imports(as % of merchandise exports) in Macedonia in 2001 to that in 2002?
Your answer should be compact. 1.13. What is the ratio of the Imports(as % of merchandise exports) of Bulgaria in 2001 to that in 2003?
Offer a very short reply. 0.86. What is the ratio of the Imports(as % of merchandise exports) of Kuwait in 2001 to that in 2003?
Keep it short and to the point. 1.1. What is the ratio of the Imports(as % of merchandise exports) of Lesotho in 2001 to that in 2003?
Your response must be concise. 1.25. What is the ratio of the Imports(as % of merchandise exports) of Macedonia in 2001 to that in 2003?
Make the answer very short. 1.15. What is the ratio of the Imports(as % of merchandise exports) in Bulgaria in 2001 to that in 2004?
Offer a terse response. 0.96. What is the ratio of the Imports(as % of merchandise exports) in Kuwait in 2001 to that in 2004?
Keep it short and to the point. 1.49. What is the ratio of the Imports(as % of merchandise exports) in Lesotho in 2001 to that in 2004?
Give a very brief answer. 1.11. What is the ratio of the Imports(as % of merchandise exports) of Macedonia in 2001 to that in 2004?
Offer a terse response. 1.24. What is the ratio of the Imports(as % of merchandise exports) in Bulgaria in 2001 to that in 2008?
Offer a very short reply. 1.33. What is the ratio of the Imports(as % of merchandise exports) of Kuwait in 2001 to that in 2008?
Your answer should be compact. 0.6. What is the ratio of the Imports(as % of merchandise exports) in Lesotho in 2001 to that in 2008?
Provide a succinct answer. 0.49. What is the ratio of the Imports(as % of merchandise exports) in Macedonia in 2001 to that in 2008?
Provide a succinct answer. 2.09. What is the ratio of the Imports(as % of merchandise exports) of Bulgaria in 2002 to that in 2003?
Give a very brief answer. 0.84. What is the ratio of the Imports(as % of merchandise exports) of Kuwait in 2002 to that in 2003?
Your answer should be compact. 1.02. What is the ratio of the Imports(as % of merchandise exports) of Lesotho in 2002 to that in 2003?
Offer a very short reply. 1.07. What is the ratio of the Imports(as % of merchandise exports) of Macedonia in 2002 to that in 2003?
Your answer should be compact. 1.02. What is the ratio of the Imports(as % of merchandise exports) of Bulgaria in 2002 to that in 2004?
Your response must be concise. 0.94. What is the ratio of the Imports(as % of merchandise exports) in Kuwait in 2002 to that in 2004?
Offer a very short reply. 1.38. What is the ratio of the Imports(as % of merchandise exports) of Lesotho in 2002 to that in 2004?
Provide a short and direct response. 0.95. What is the ratio of the Imports(as % of merchandise exports) of Macedonia in 2002 to that in 2004?
Your answer should be compact. 1.1. What is the ratio of the Imports(as % of merchandise exports) of Bulgaria in 2002 to that in 2008?
Keep it short and to the point. 1.3. What is the ratio of the Imports(as % of merchandise exports) of Kuwait in 2002 to that in 2008?
Your answer should be compact. 0.56. What is the ratio of the Imports(as % of merchandise exports) of Lesotho in 2002 to that in 2008?
Offer a terse response. 0.42. What is the ratio of the Imports(as % of merchandise exports) of Macedonia in 2002 to that in 2008?
Your answer should be very brief. 1.85. What is the ratio of the Imports(as % of merchandise exports) of Bulgaria in 2003 to that in 2004?
Offer a terse response. 1.12. What is the ratio of the Imports(as % of merchandise exports) in Kuwait in 2003 to that in 2004?
Offer a terse response. 1.36. What is the ratio of the Imports(as % of merchandise exports) in Lesotho in 2003 to that in 2004?
Ensure brevity in your answer.  0.89. What is the ratio of the Imports(as % of merchandise exports) in Macedonia in 2003 to that in 2004?
Provide a short and direct response. 1.08. What is the ratio of the Imports(as % of merchandise exports) of Bulgaria in 2003 to that in 2008?
Your response must be concise. 1.55. What is the ratio of the Imports(as % of merchandise exports) of Kuwait in 2003 to that in 2008?
Ensure brevity in your answer.  0.55. What is the ratio of the Imports(as % of merchandise exports) in Lesotho in 2003 to that in 2008?
Your answer should be very brief. 0.39. What is the ratio of the Imports(as % of merchandise exports) of Macedonia in 2003 to that in 2008?
Provide a succinct answer. 1.82. What is the ratio of the Imports(as % of merchandise exports) in Bulgaria in 2004 to that in 2008?
Ensure brevity in your answer.  1.39. What is the ratio of the Imports(as % of merchandise exports) of Kuwait in 2004 to that in 2008?
Your answer should be very brief. 0.41. What is the ratio of the Imports(as % of merchandise exports) of Lesotho in 2004 to that in 2008?
Provide a succinct answer. 0.44. What is the ratio of the Imports(as % of merchandise exports) in Macedonia in 2004 to that in 2008?
Make the answer very short. 1.68. What is the difference between the highest and the second highest Imports(as % of merchandise exports) in Bulgaria?
Your response must be concise. 0.17. What is the difference between the highest and the second highest Imports(as % of merchandise exports) in Kuwait?
Provide a succinct answer. 0.23. What is the difference between the highest and the second highest Imports(as % of merchandise exports) of Lesotho?
Provide a short and direct response. 0.98. What is the difference between the highest and the second highest Imports(as % of merchandise exports) in Macedonia?
Ensure brevity in your answer.  0.01. What is the difference between the highest and the lowest Imports(as % of merchandise exports) of Bulgaria?
Give a very brief answer. 0.56. What is the difference between the highest and the lowest Imports(as % of merchandise exports) in Kuwait?
Make the answer very short. 0.37. What is the difference between the highest and the lowest Imports(as % of merchandise exports) of Lesotho?
Provide a succinct answer. 1.16. What is the difference between the highest and the lowest Imports(as % of merchandise exports) of Macedonia?
Give a very brief answer. 0.96. 